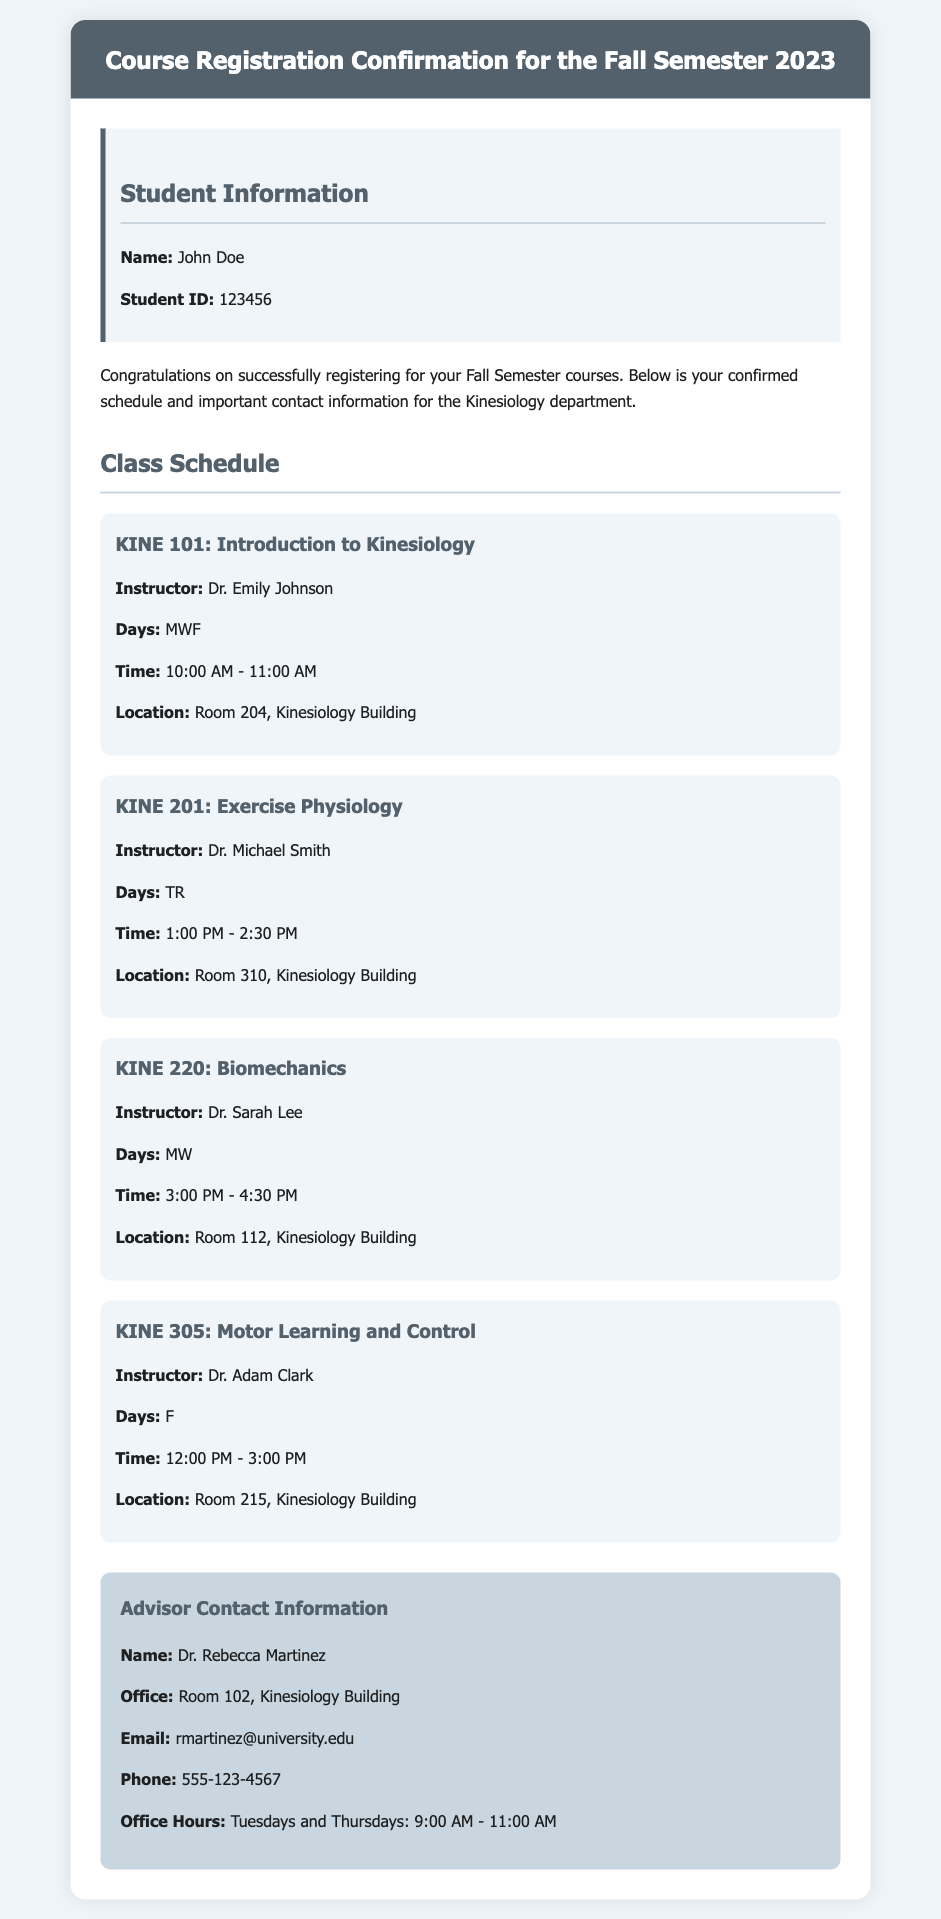what is the name of the student? The document provides the student's name under "Student Information" as John Doe.
Answer: John Doe what is the student ID? The student ID is stated in the "Student Information" section as 123456.
Answer: 123456 who is the instructor for KINE 201? The instructor's name for KINE 201 can be found in the course schedule. It is listed as Dr. Michael Smith.
Answer: Dr. Michael Smith what time does KINE 305 take place? The time for KINE 305 is indicated in the class schedule, which shows it occurs from 12:00 PM to 3:00 PM on Fridays.
Answer: 12:00 PM - 3:00 PM how many classes are scheduled on Mondays? The schedule lists two classes on Mondays: KINE 101 and KINE 220, indicating there are two classes.
Answer: 2 what is the office number of the advisor? The advisor's office number is specified in the "Advisor Contact Information" section as Room 102.
Answer: Room 102 what days are the office hours for the advisor? The document indicates that the advisor's office hours are on Tuesdays and Thursdays, which answers the query.
Answer: Tuesdays and Thursdays which class has the longest duration? By evaluating the provided class times, KINE 305 is noted to last for 3 hours, making it the longest.
Answer: KINE 305 